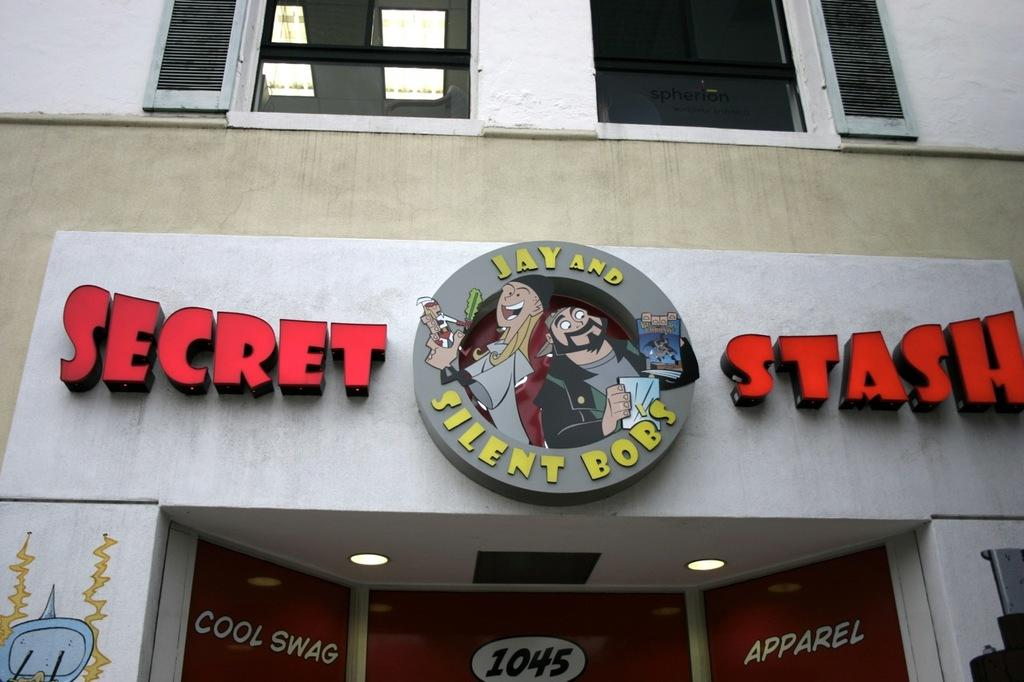<image>
Create a compact narrative representing the image presented. a storefront that says 'secret stash' above the front doors 